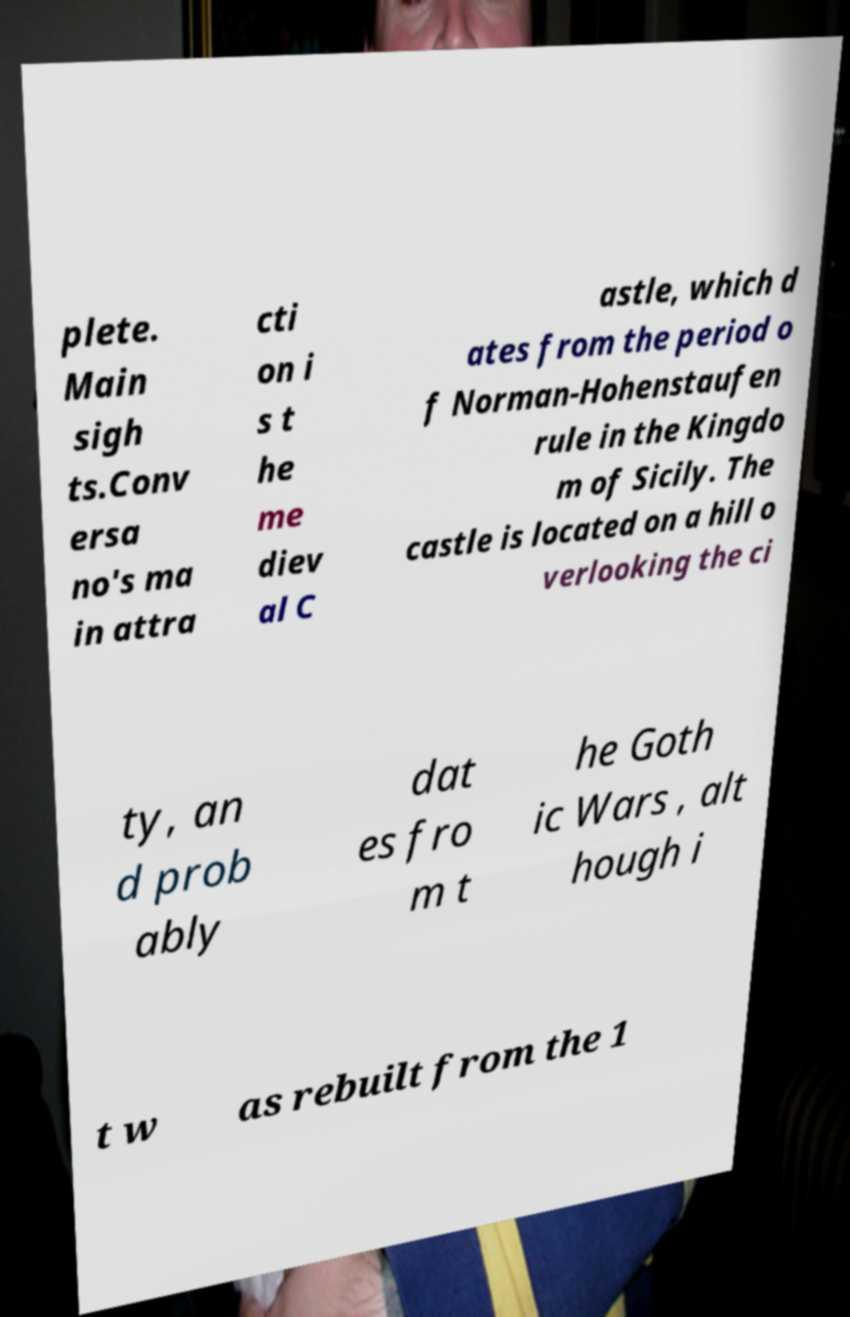Please read and relay the text visible in this image. What does it say? plete. Main sigh ts.Conv ersa no's ma in attra cti on i s t he me diev al C astle, which d ates from the period o f Norman-Hohenstaufen rule in the Kingdo m of Sicily. The castle is located on a hill o verlooking the ci ty, an d prob ably dat es fro m t he Goth ic Wars , alt hough i t w as rebuilt from the 1 